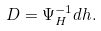<formula> <loc_0><loc_0><loc_500><loc_500>D = \Psi _ { H } ^ { - 1 } d h .</formula> 